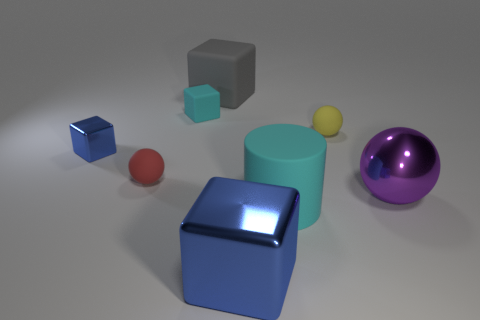Is the color of the tiny metallic thing the same as the big metallic block?
Provide a short and direct response. Yes. Is the number of big blue shiny things that are behind the large purple ball less than the number of things in front of the yellow matte sphere?
Give a very brief answer. Yes. There is a blue object that is behind the purple ball; does it have the same shape as the large matte object that is to the right of the large gray rubber thing?
Your response must be concise. No. The blue object to the right of the metal cube on the left side of the small cyan matte object is what shape?
Provide a succinct answer. Cube. There is a matte object that is the same color as the small rubber cube; what size is it?
Keep it short and to the point. Large. Is there a big cube that has the same material as the large gray object?
Offer a very short reply. No. There is a large cube in front of the large cylinder; what material is it?
Provide a succinct answer. Metal. What material is the big gray cube?
Give a very brief answer. Rubber. Does the large cube that is behind the big blue metallic block have the same material as the large cyan object?
Ensure brevity in your answer.  Yes. Are there fewer tiny things that are in front of the tiny yellow matte thing than yellow matte balls?
Ensure brevity in your answer.  No. 